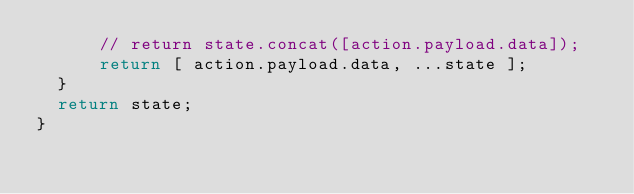Convert code to text. <code><loc_0><loc_0><loc_500><loc_500><_JavaScript_>      // return state.concat([action.payload.data]);
      return [ action.payload.data, ...state ];
  }
  return state;
}
</code> 